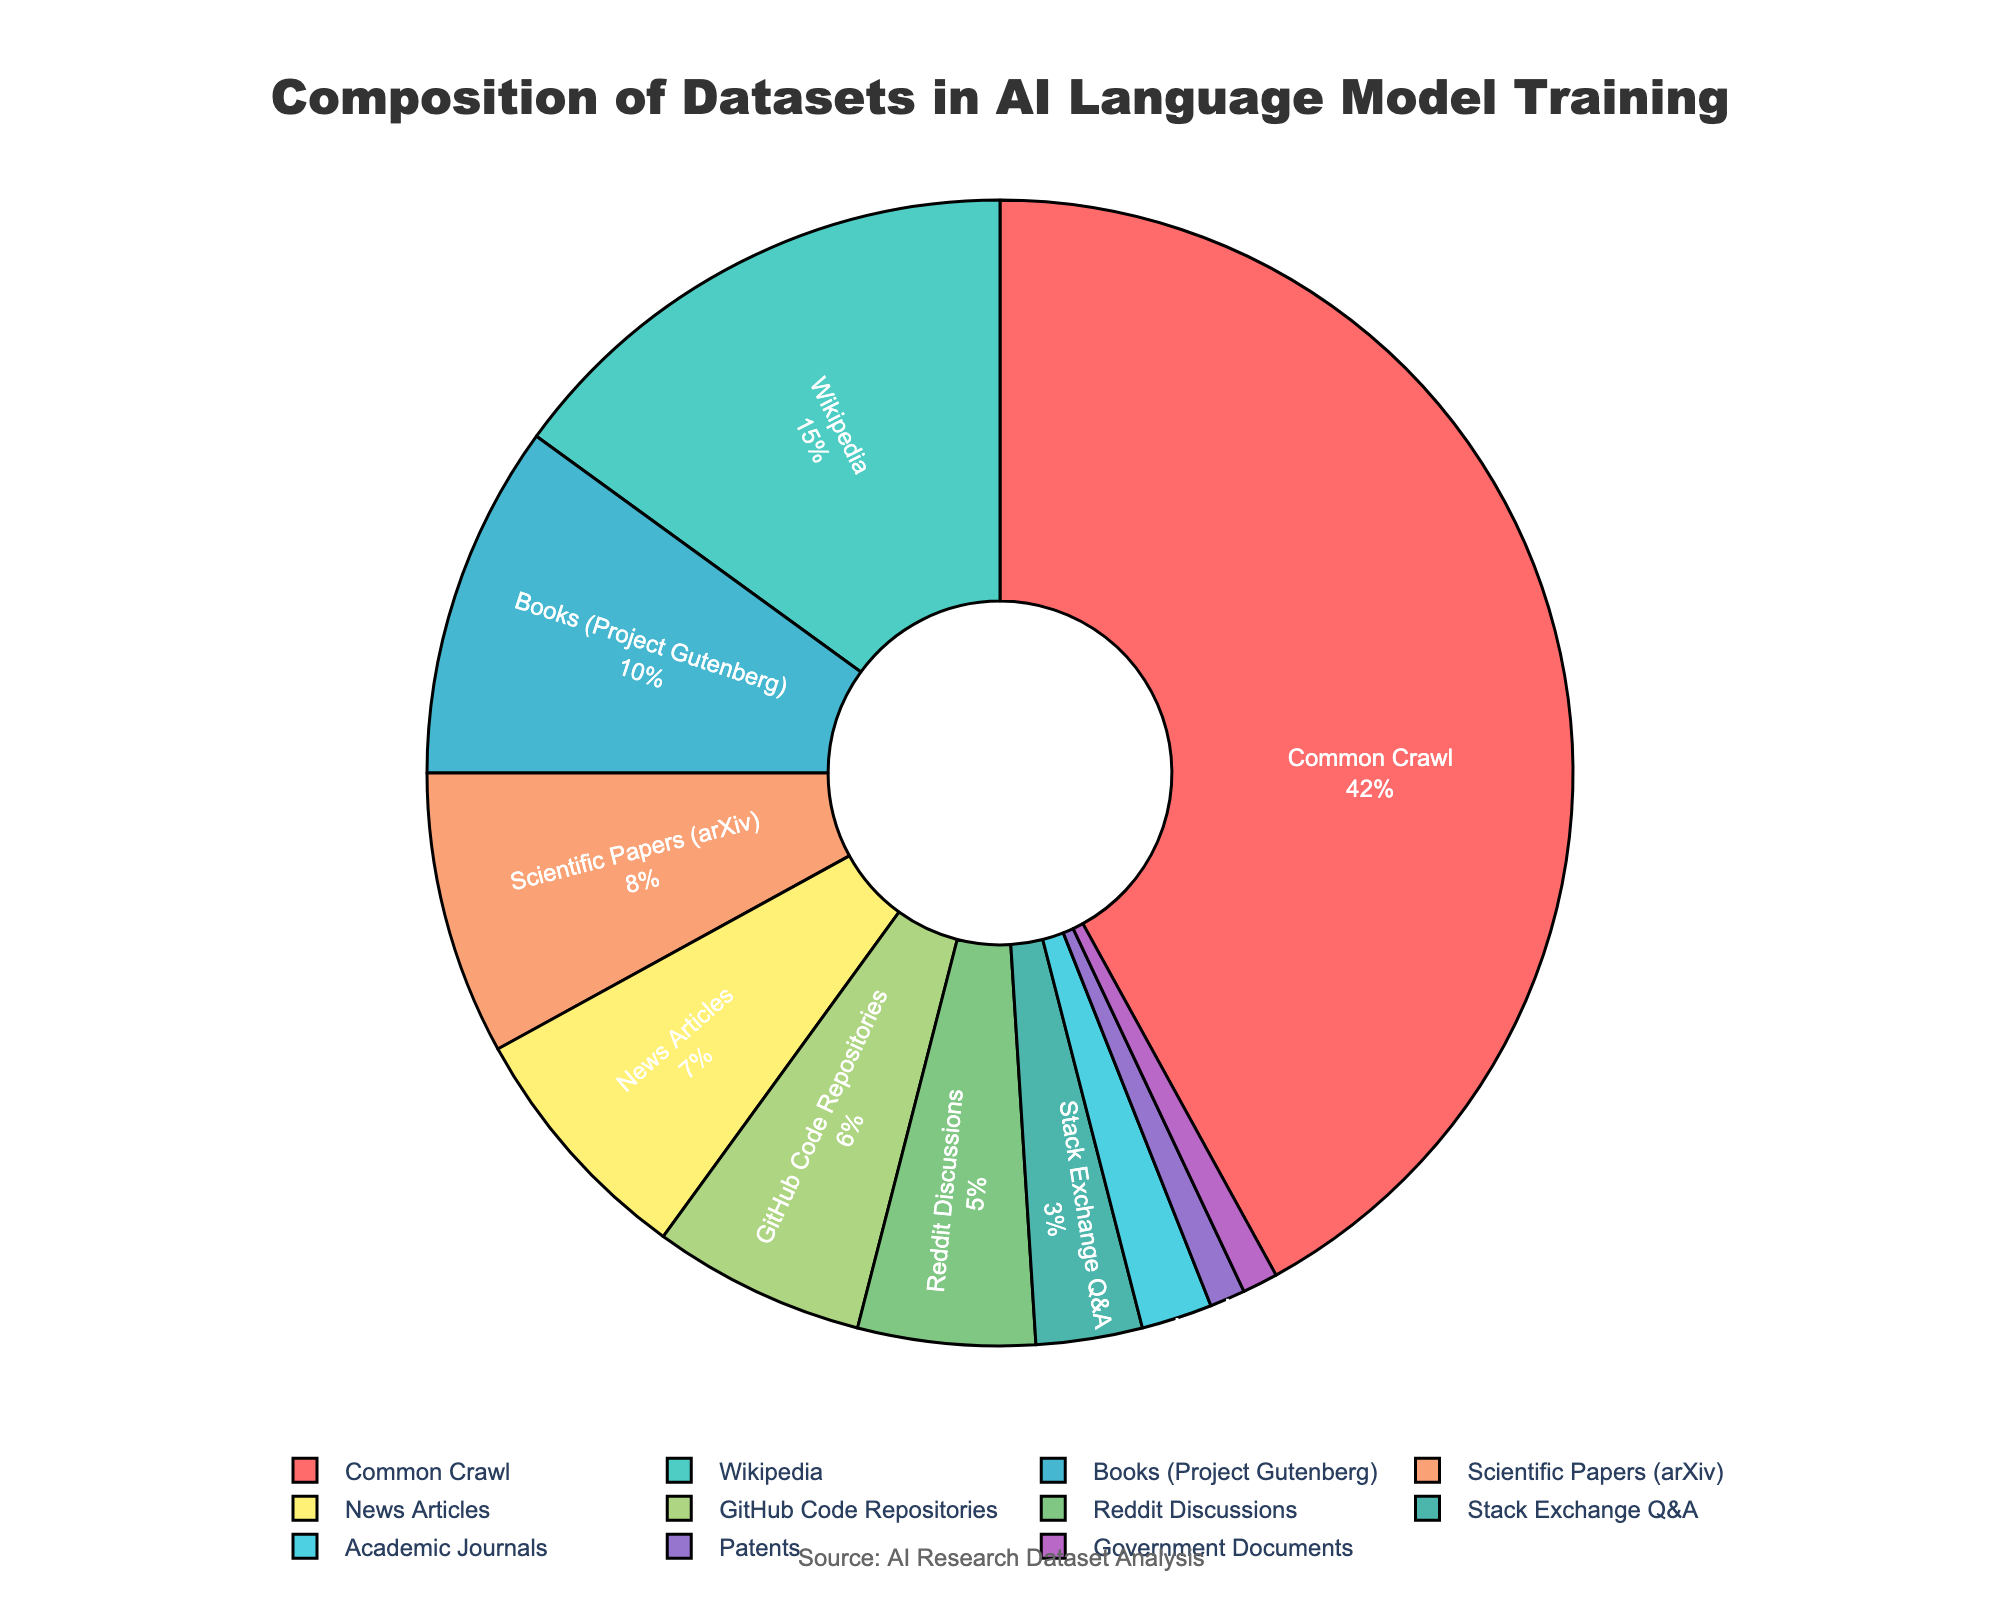Which category has the highest percentage in the dataset composition? By examining the pie chart, the largest segment corresponds to "Common Crawl" with a visual highlight of 42%.
Answer: Common Crawl What's the combined percentage of 'Wikipedia' and 'Books (Project Gutenberg)'? To find the combined percentage, add the values for 'Wikipedia' (15%) and 'Books (Project Gutenberg)' (10%). 15% + 10% = 25%.
Answer: 25% How many data sources make up less than 5% of the dataset composition? By examining the segments visually, the categories 'Stack Exchange Q&A' (3%), 'Academic Journals' (2%), 'Patents' (1%), and 'Government Documents' (1%) are each less than 5%. There are 4 such categories.
Answer: 4 Which dataset category is represented by an orange segment in the pie chart? To identify the orange segment, visually match the color. The orange segment represents 'Books (Project Gutenberg)'.
Answer: Books (Project Gutenberg) What is the difference in percentage between 'Scientific Papers (arXiv)' and 'News Articles'? Subtract the percentage of 'News Articles' (7%) from 'Scientific Papers (arXiv)' (8%). 8% - 7% = 1%.
Answer: 1% Which category has a smaller percentage, 'Reddit Discussions' or 'GitHub Code Repositories', and by how much? Compare 'Reddit Discussions' (5%) and 'GitHub Code Repositories' (6%). 'Reddit Discussions' has 1% less than 'GitHub Code Repositories'. 6% - 5% = 1%.
Answer: Reddit Discussions by 1% What is the total percentage of the datasets that each makes up more than 5% of the dataset composition? Add the percentages of 'Common Crawl' (42%), 'Wikipedia' (15%), 'Books (Project Gutenberg)' (10%), 'Scientific Papers (arXiv)' (8%), 'News Articles' (7%), and 'GitHub Code Repositories' (6%). 42% + 15% + 10% + 8% + 7% + 6% = 88%.
Answer: 88% What's the difference in the percentage between the largest and smallest dataset categories? Subtract the smallest value (‘Patents’ and ‘Government Documents’ at 1%) from the largest value (‘Common Crawl’ at 42%). 42% - 1% = 41%.
Answer: 41% What is the combined percentage of all categories that are represented in shades of green? Identify the green colored segments which are 'Scientific Papers (arXiv)' (8%) and 'Government Documents' (1%). Add them together: 8% + 1% = 9%.
Answer: 9% What's the average percentage of the 'Common Crawl', 'Wikipedia', and 'Books (Project Gutenberg)' datasets? Add the percentages of these categories: 42% (Common Crawl) + 15% (Wikipedia) + 10% (Books). Then divide by the number of categories: (42% + 15% + 10%) / 3 = 67% / 3 ≈ 22.33%.
Answer: 22.33% 